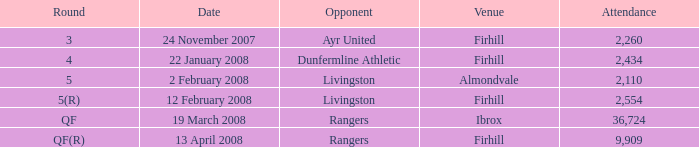What day was the game held at Firhill against AYR United? 24 November 2007. 